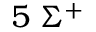<formula> <loc_0><loc_0><loc_500><loc_500>5 \, \Sigma ^ { + }</formula> 